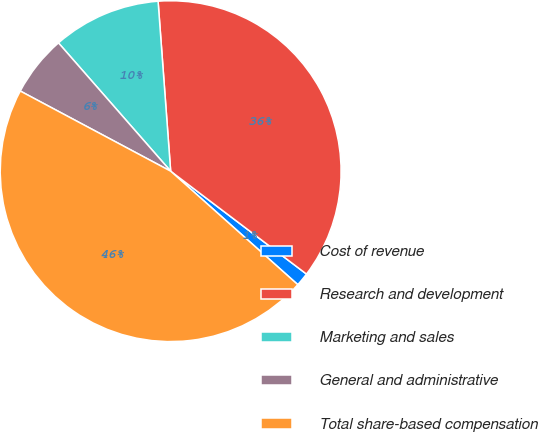<chart> <loc_0><loc_0><loc_500><loc_500><pie_chart><fcel>Cost of revenue<fcel>Research and development<fcel>Marketing and sales<fcel>General and administrative<fcel>Total share-based compensation<nl><fcel>1.28%<fcel>36.49%<fcel>10.26%<fcel>5.77%<fcel>46.19%<nl></chart> 